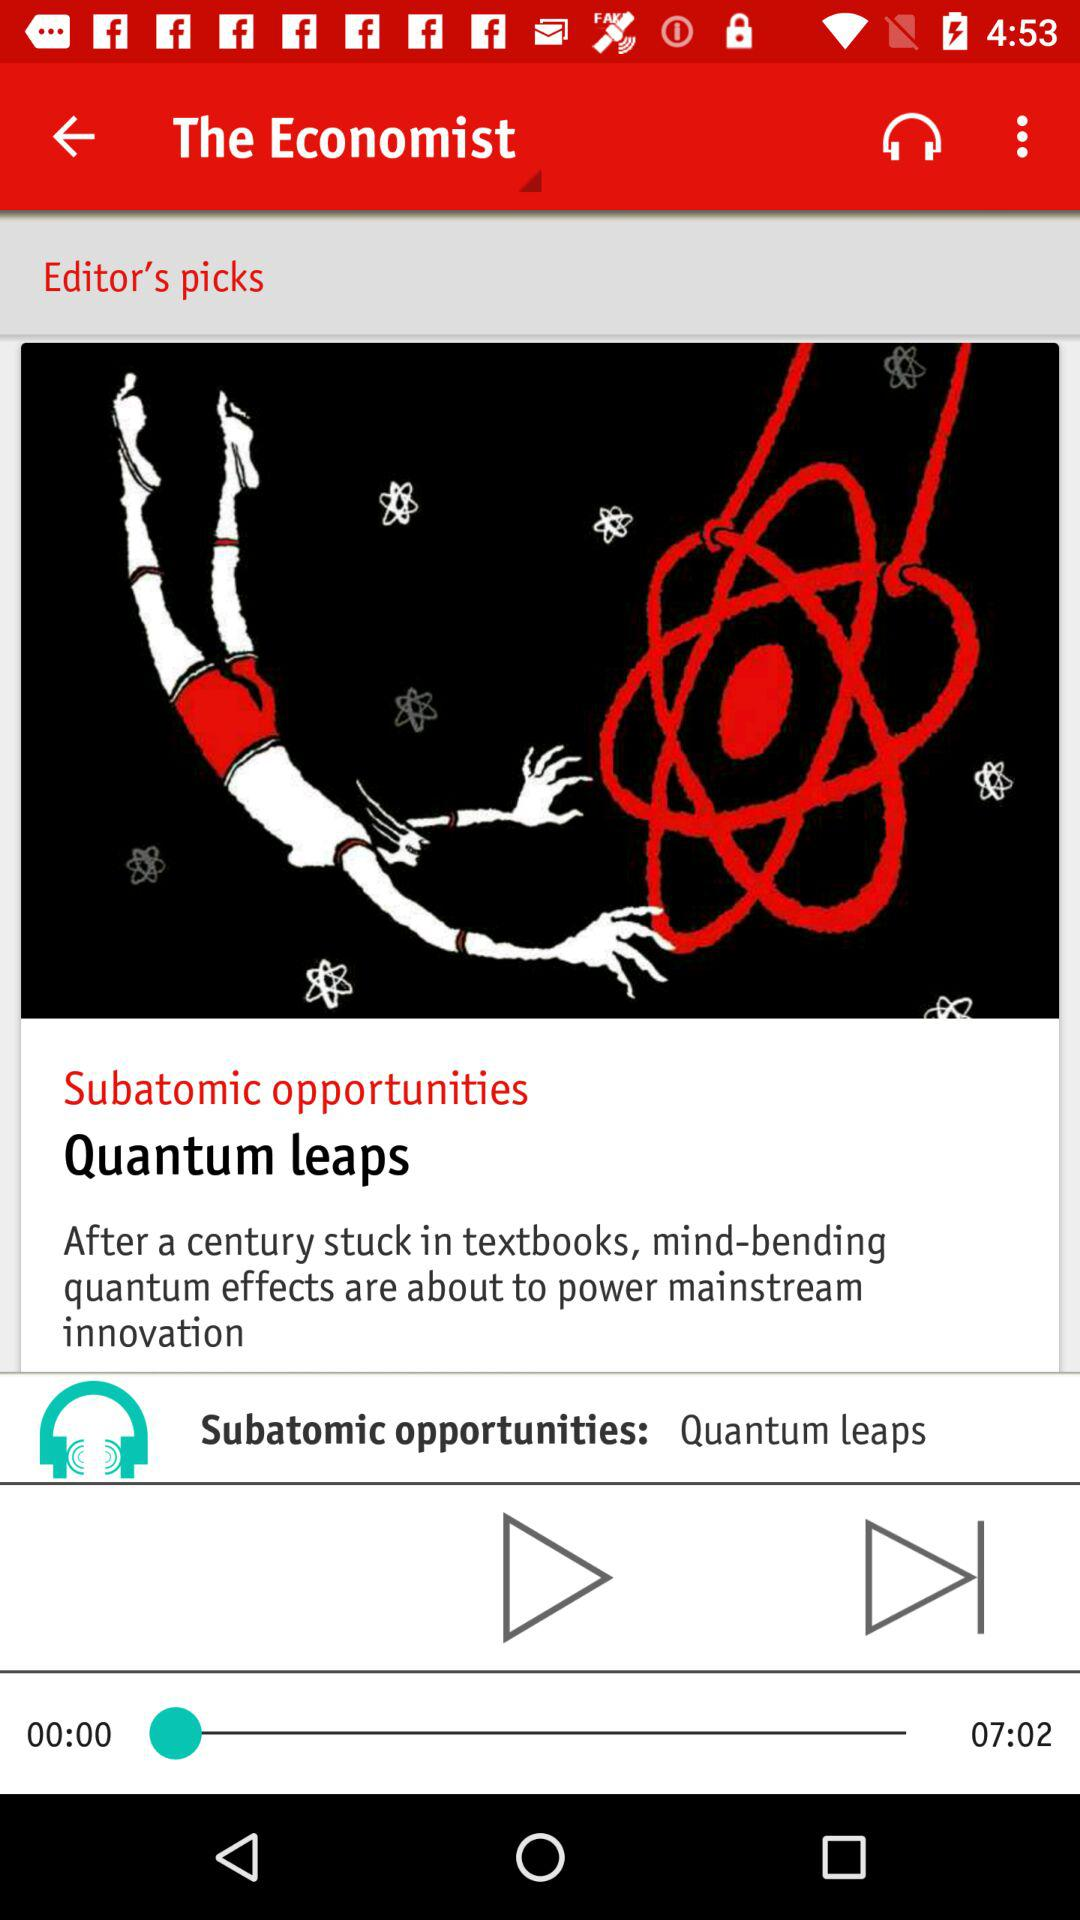What is the total duration? The total duration is 7 minutes 2 seconds. 